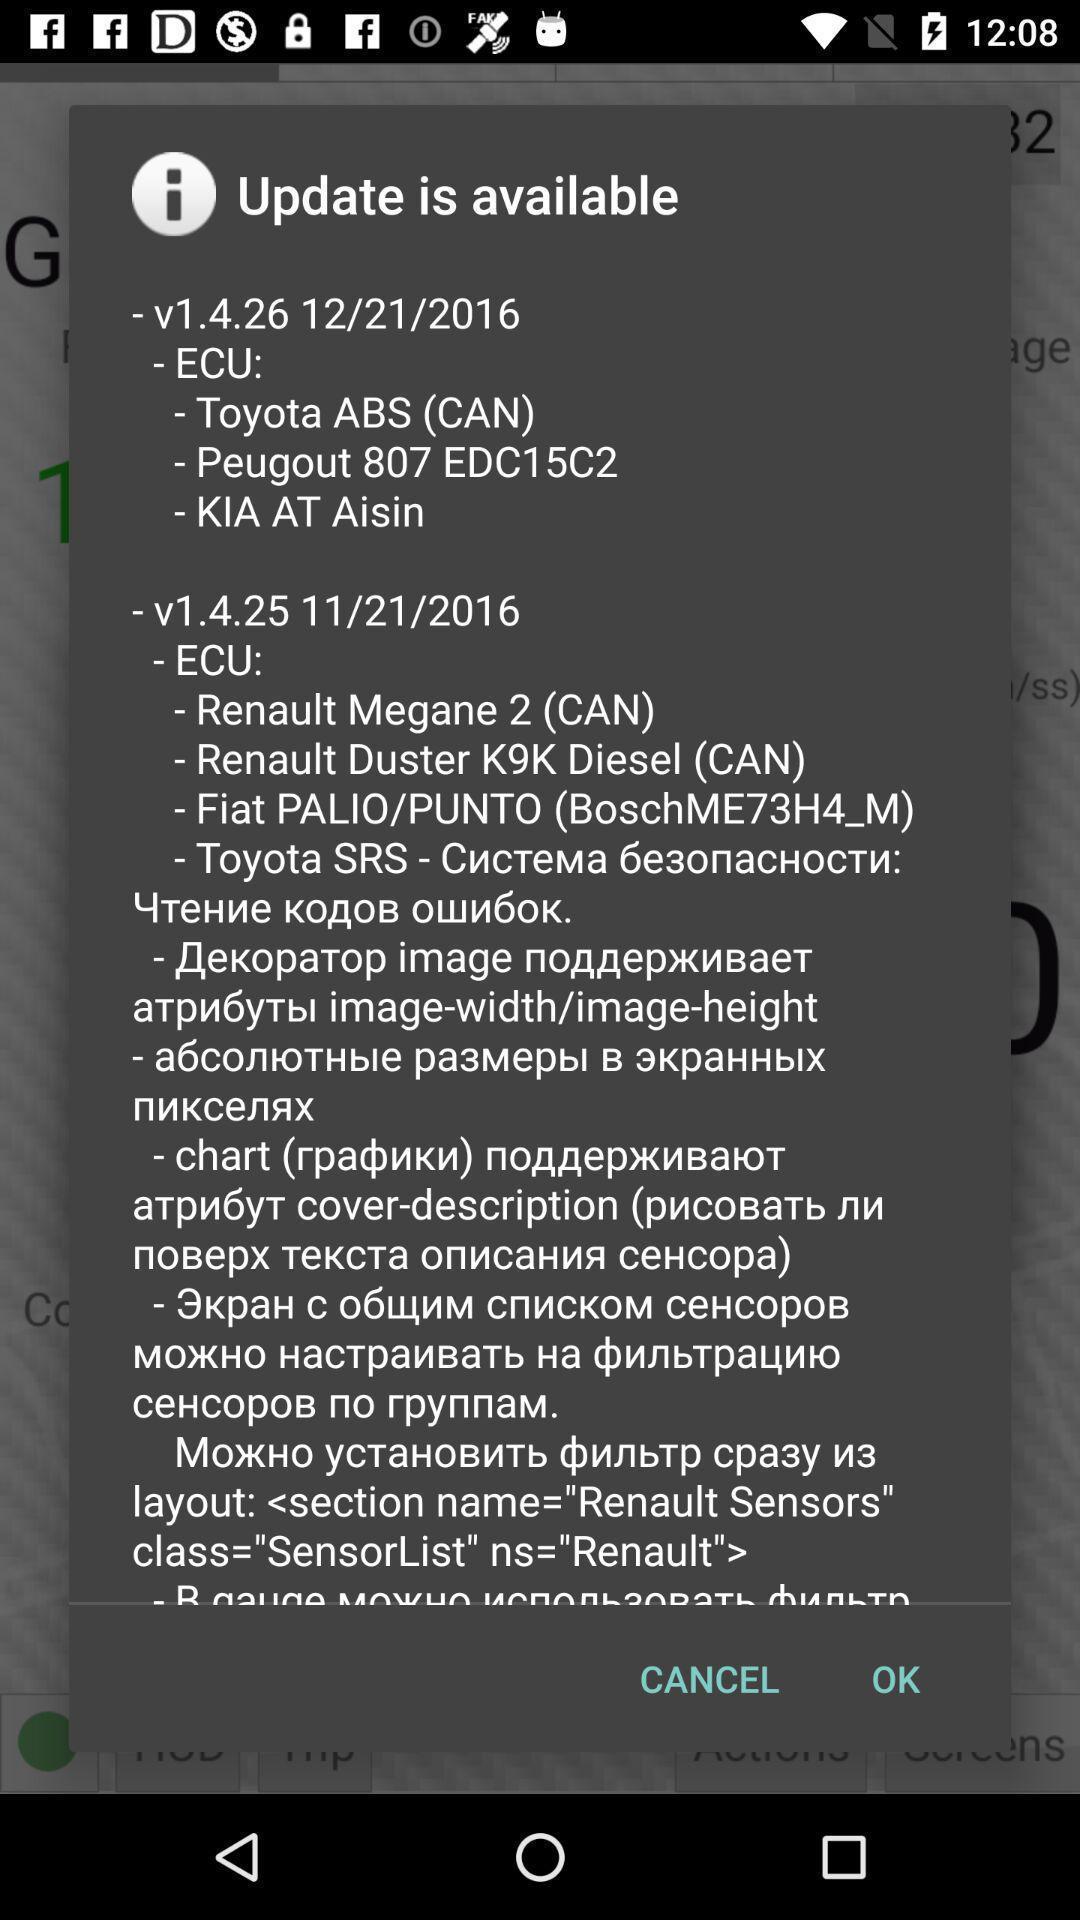Explain what's happening in this screen capture. Pop up window displayed for new update. 